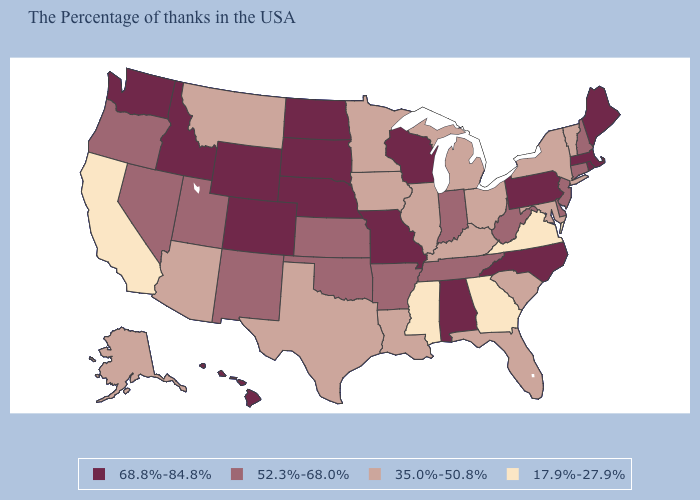Which states have the highest value in the USA?
Short answer required. Maine, Massachusetts, Rhode Island, Pennsylvania, North Carolina, Alabama, Wisconsin, Missouri, Nebraska, South Dakota, North Dakota, Wyoming, Colorado, Idaho, Washington, Hawaii. What is the highest value in states that border Utah?
Short answer required. 68.8%-84.8%. Which states have the lowest value in the MidWest?
Give a very brief answer. Ohio, Michigan, Illinois, Minnesota, Iowa. What is the value of Virginia?
Quick response, please. 17.9%-27.9%. What is the highest value in the West ?
Give a very brief answer. 68.8%-84.8%. Does Massachusetts have the highest value in the USA?
Answer briefly. Yes. Does North Carolina have the highest value in the South?
Short answer required. Yes. What is the value of West Virginia?
Keep it brief. 52.3%-68.0%. Name the states that have a value in the range 52.3%-68.0%?
Be succinct. New Hampshire, Connecticut, New Jersey, Delaware, West Virginia, Indiana, Tennessee, Arkansas, Kansas, Oklahoma, New Mexico, Utah, Nevada, Oregon. Which states have the lowest value in the USA?
Concise answer only. Virginia, Georgia, Mississippi, California. Which states hav the highest value in the South?
Answer briefly. North Carolina, Alabama. Among the states that border Arkansas , does Mississippi have the lowest value?
Keep it brief. Yes. What is the highest value in the MidWest ?
Give a very brief answer. 68.8%-84.8%. Does Utah have the highest value in the West?
Write a very short answer. No. What is the lowest value in the South?
Be succinct. 17.9%-27.9%. 